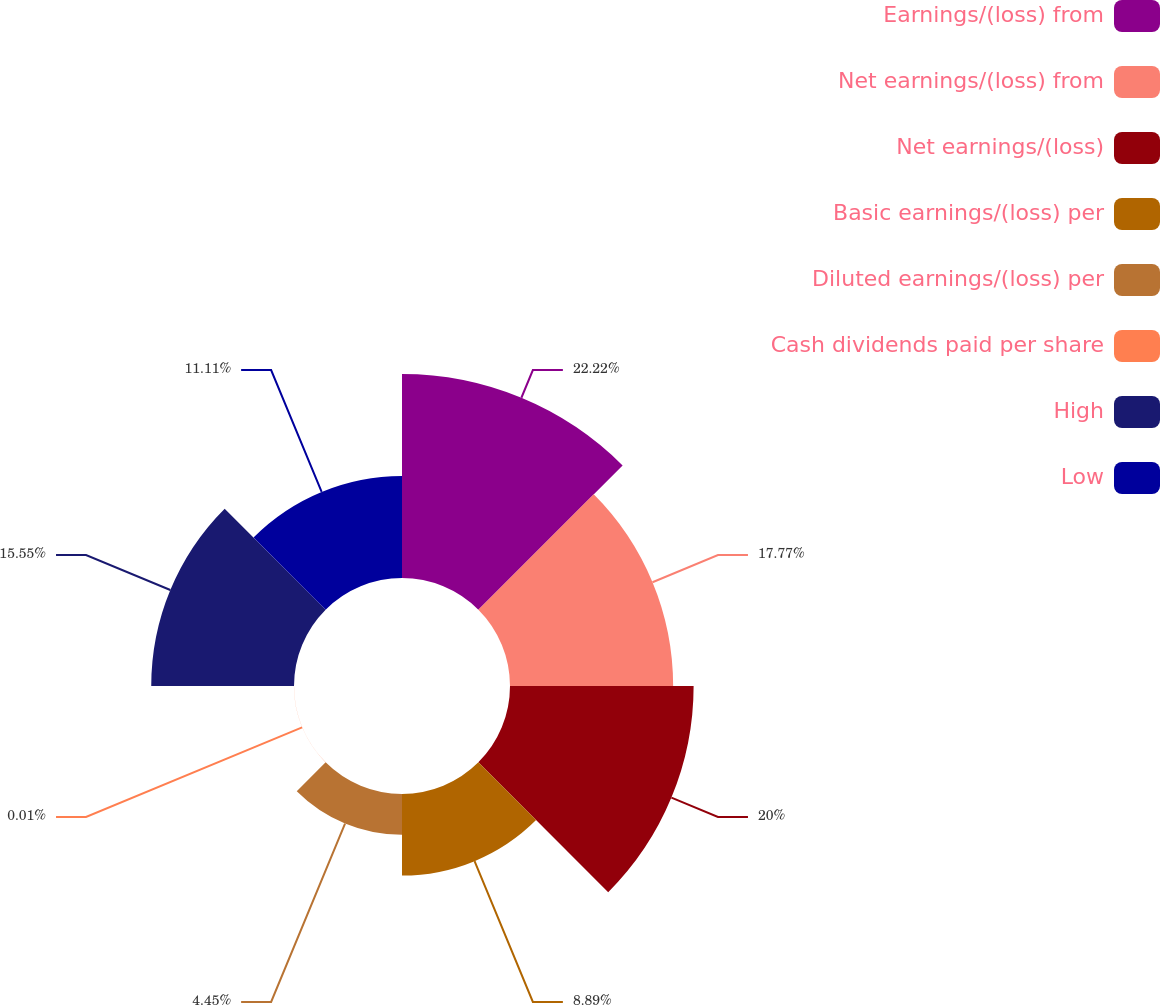Convert chart. <chart><loc_0><loc_0><loc_500><loc_500><pie_chart><fcel>Earnings/(loss) from<fcel>Net earnings/(loss) from<fcel>Net earnings/(loss)<fcel>Basic earnings/(loss) per<fcel>Diluted earnings/(loss) per<fcel>Cash dividends paid per share<fcel>High<fcel>Low<nl><fcel>22.22%<fcel>17.77%<fcel>20.0%<fcel>8.89%<fcel>4.45%<fcel>0.01%<fcel>15.55%<fcel>11.11%<nl></chart> 